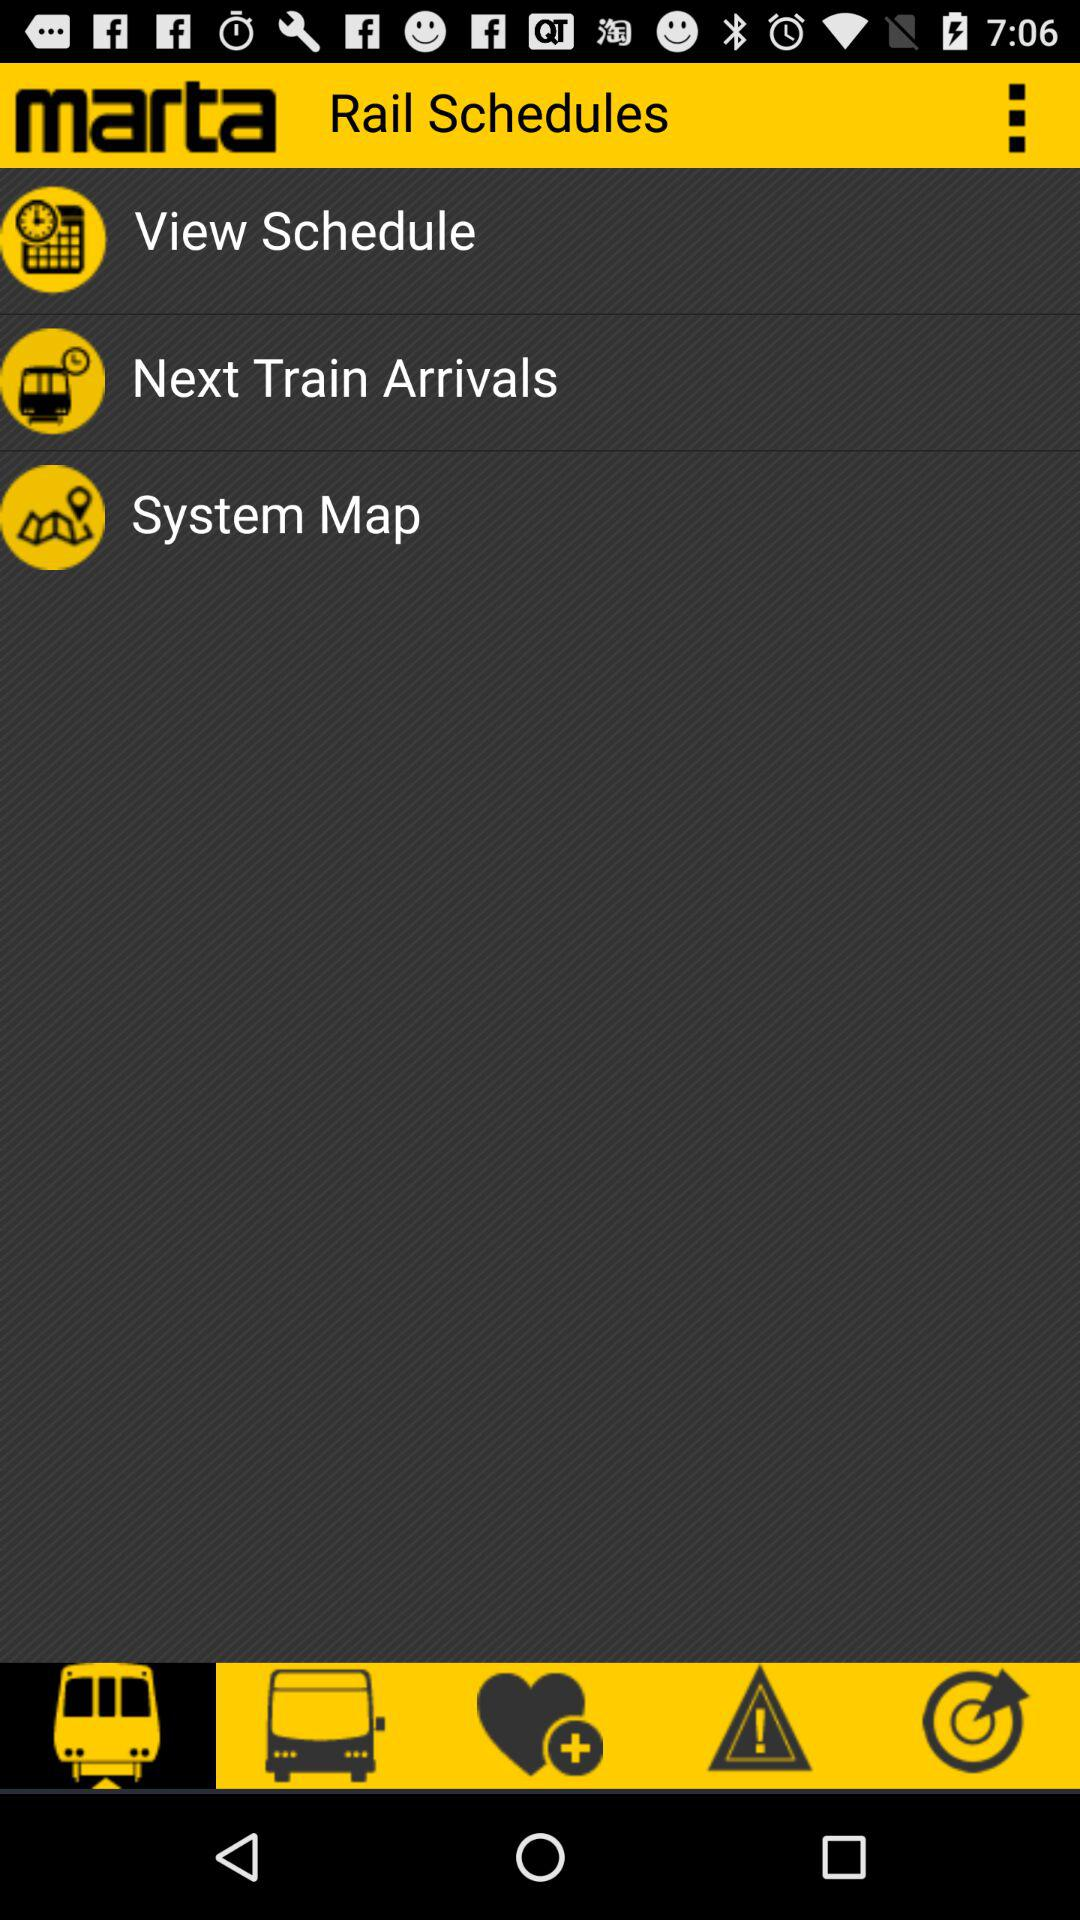What is the name of the application? The name of the application is "marta". 